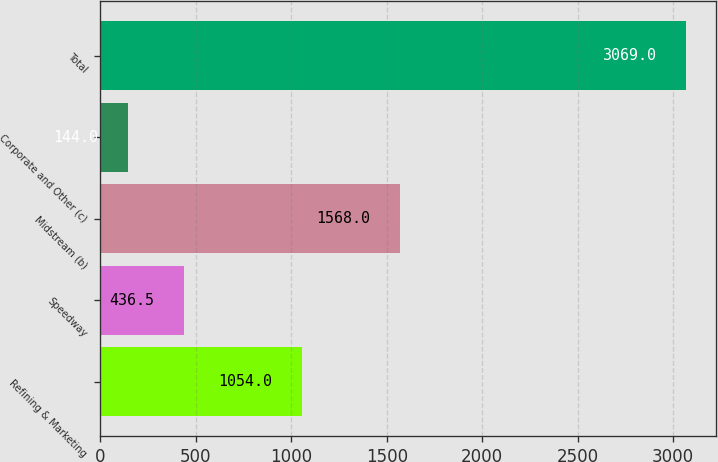Convert chart to OTSL. <chart><loc_0><loc_0><loc_500><loc_500><bar_chart><fcel>Refining & Marketing<fcel>Speedway<fcel>Midstream (b)<fcel>Corporate and Other (c)<fcel>Total<nl><fcel>1054<fcel>436.5<fcel>1568<fcel>144<fcel>3069<nl></chart> 